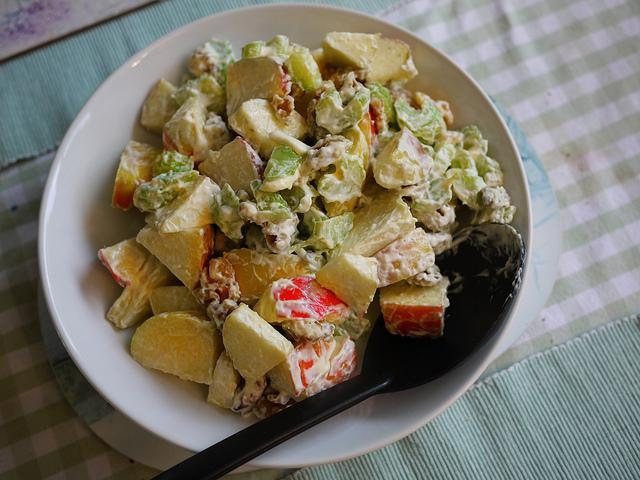What type of utensil is in the bowl?

Choices:
A) scissor
B) spoon
C) knife
D) fork spoon 